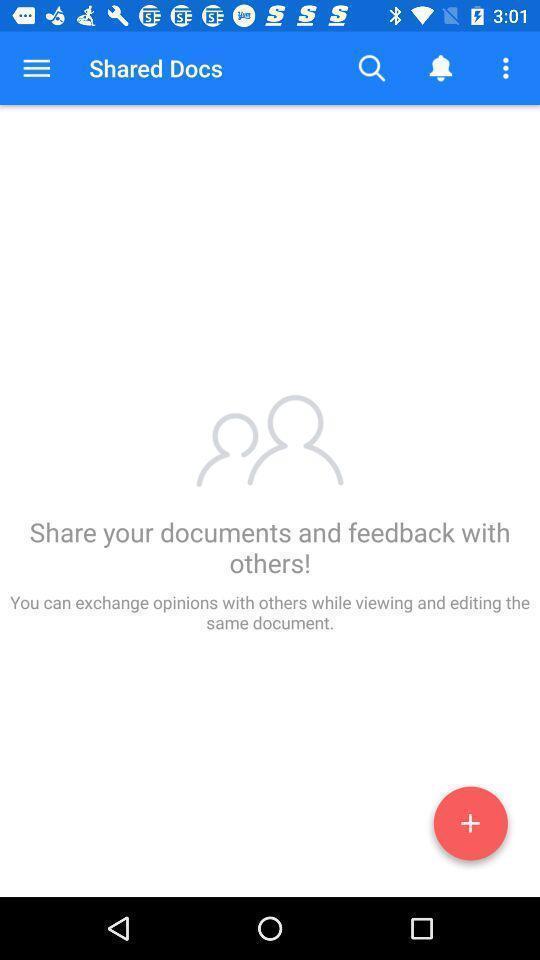What can you discern from this picture? Shared docs page in business app. 